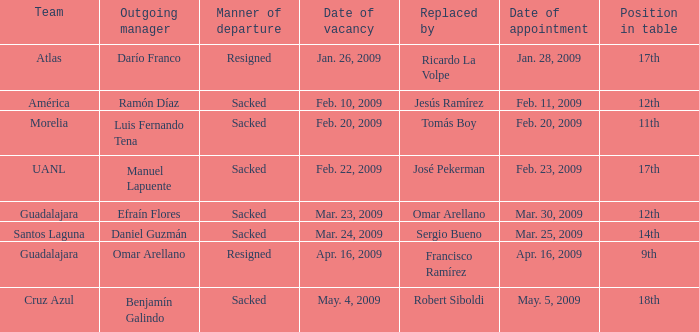What is the rank in the table when substituted by "josé pekerman"? 17th. 